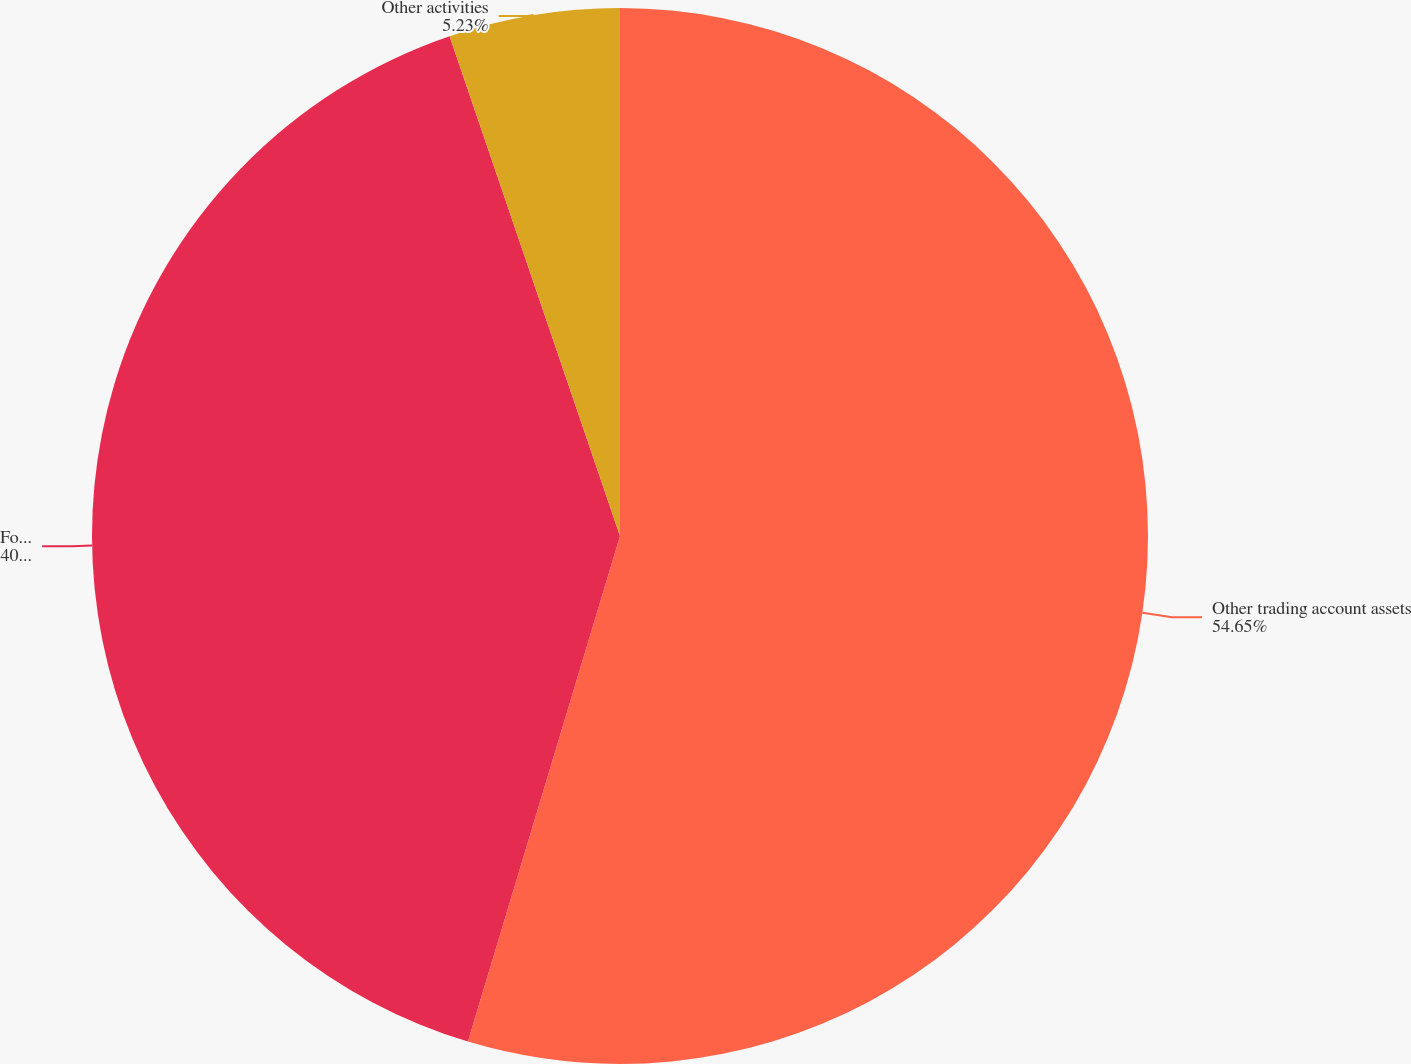Convert chart to OTSL. <chart><loc_0><loc_0><loc_500><loc_500><pie_chart><fcel>Other trading account assets<fcel>Foreign currency exchange<fcel>Other activities<nl><fcel>54.65%<fcel>40.12%<fcel>5.23%<nl></chart> 